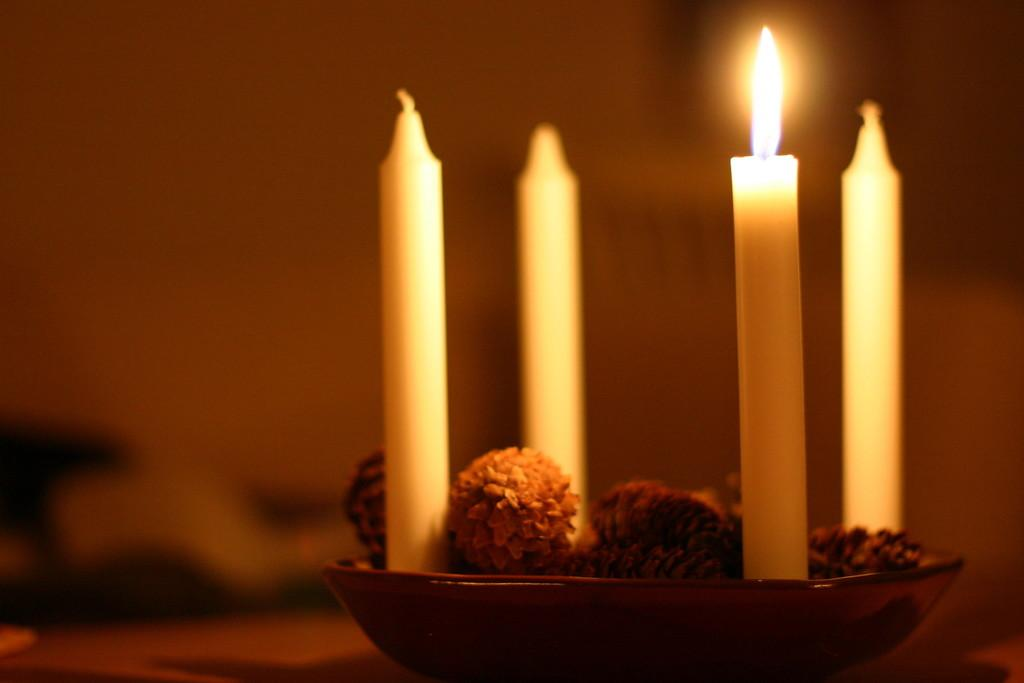What is the color of the plate in the image? The plate in the image is brown. What is placed on the plate? There are candles on the plate, as well as other unspecified things. Can you describe the background of the image? The background of the image is blurry. How many chickens are present on the plate in the image? There are no chickens present on the plate in the image. What type of stone can be seen in the image? There is no stone visible in the image. 